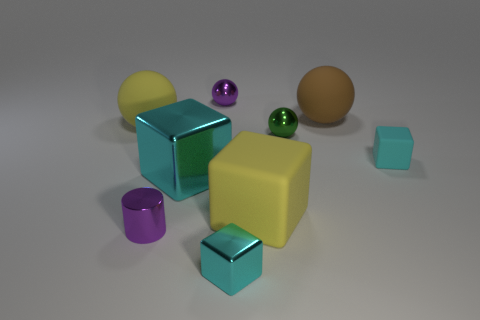Subtract all big yellow matte blocks. How many blocks are left? 3 Add 1 yellow objects. How many objects exist? 10 Subtract all yellow blocks. How many blocks are left? 3 Subtract all cylinders. How many objects are left? 8 Subtract 2 cubes. How many cubes are left? 2 Add 9 large red balls. How many large red balls exist? 9 Subtract 1 purple cylinders. How many objects are left? 8 Subtract all red cylinders. Subtract all blue blocks. How many cylinders are left? 1 Subtract all gray spheres. How many brown blocks are left? 0 Subtract all small red rubber objects. Subtract all small metal cubes. How many objects are left? 8 